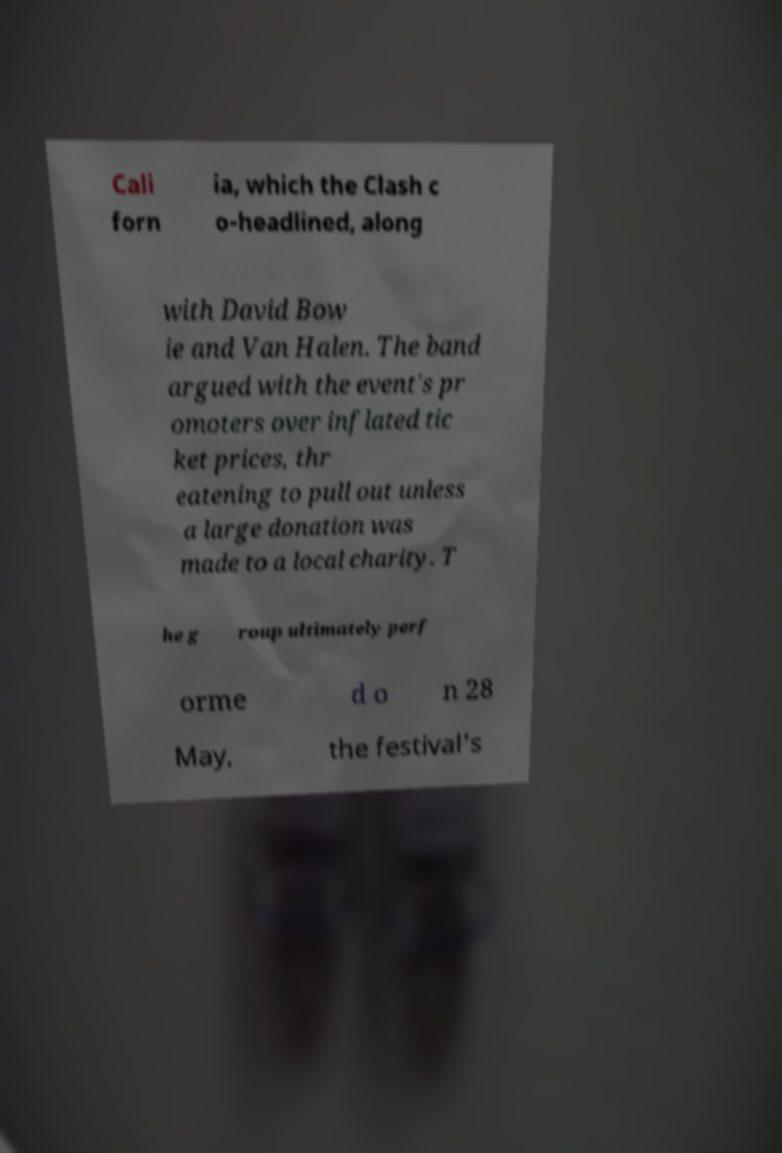Please read and relay the text visible in this image. What does it say? Cali forn ia, which the Clash c o-headlined, along with David Bow ie and Van Halen. The band argued with the event's pr omoters over inflated tic ket prices, thr eatening to pull out unless a large donation was made to a local charity. T he g roup ultimately perf orme d o n 28 May, the festival's 